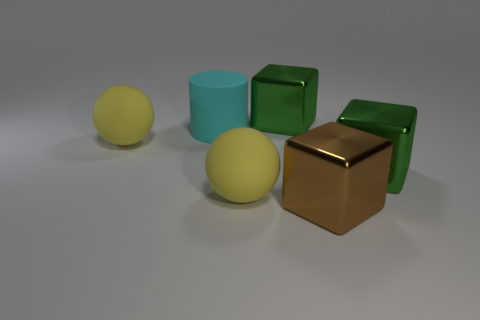Are there any big shiny things on the right side of the cyan cylinder?
Make the answer very short. Yes. There is a big cylinder that is behind the rubber object that is in front of the large green cube that is right of the brown object; what is its color?
Provide a succinct answer. Cyan. How many things are large metal blocks left of the brown block or brown shiny blocks?
Keep it short and to the point. 2. What size is the metallic cube that is to the left of the brown metallic thing?
Offer a very short reply. Large. There is a brown metal cube; is it the same size as the shiny object that is left of the brown block?
Keep it short and to the point. Yes. What color is the rubber cylinder left of the large green cube that is behind the big cyan cylinder?
Ensure brevity in your answer.  Cyan. How many other things are the same color as the large cylinder?
Offer a terse response. 0. Is the number of big blocks to the right of the big brown block greater than the number of cylinders to the left of the cyan matte cylinder?
Provide a succinct answer. Yes. How many brown cubes are to the left of the large green block behind the large cyan rubber cylinder?
Your answer should be very brief. 0. Do the big green thing that is to the right of the big brown metal thing and the big brown object have the same shape?
Provide a succinct answer. Yes. 